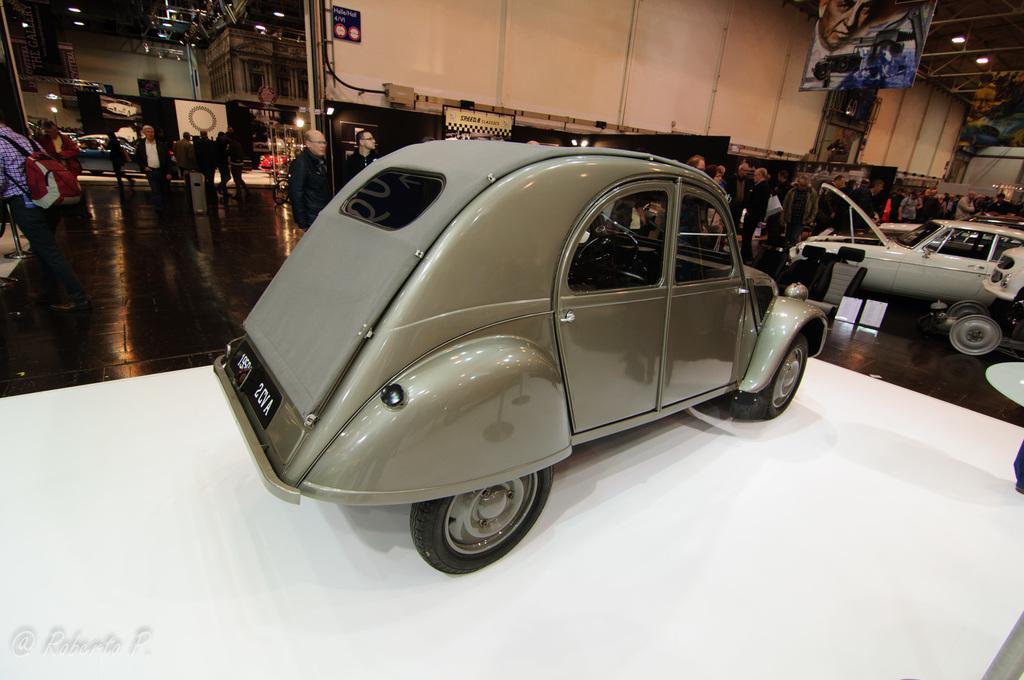Could you give a brief overview of what you see in this image? In this image we can see few vehicles. Behind the vehicle we can see a group of persons and a wall. At the top we can see a banner in which we can see a person and a board on the wall with text. At the bottom we can see white surface. In the top right, we can see a roof and lights. 